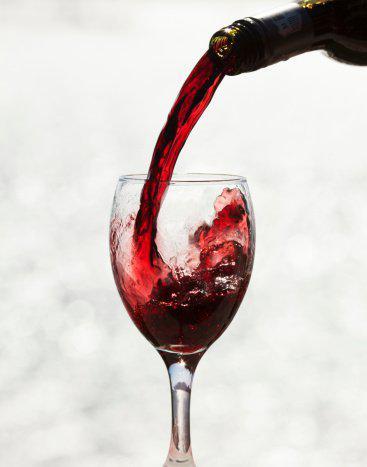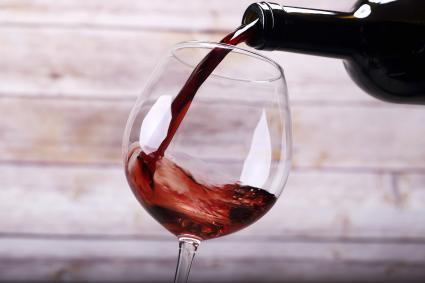The first image is the image on the left, the second image is the image on the right. Evaluate the accuracy of this statement regarding the images: "One of the images contains exactly two glasses of wine.". Is it true? Answer yes or no. No. 